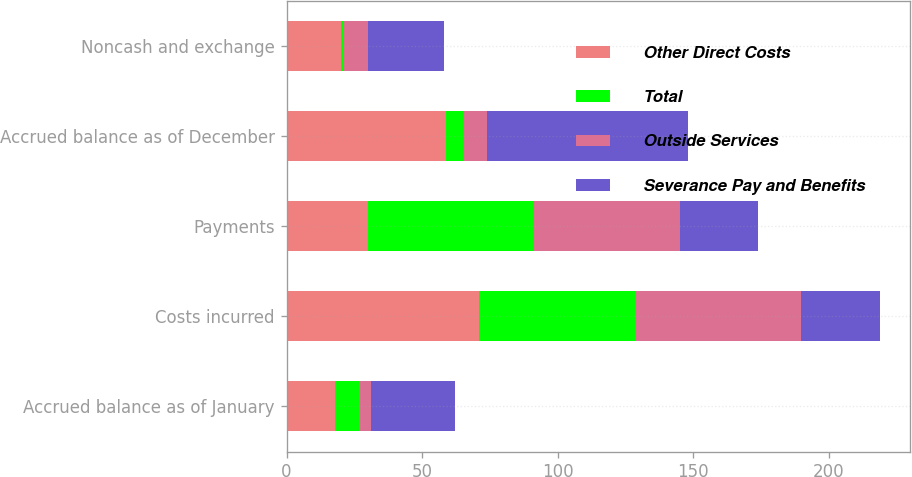Convert chart. <chart><loc_0><loc_0><loc_500><loc_500><stacked_bar_chart><ecel><fcel>Accrued balance as of January<fcel>Costs incurred<fcel>Payments<fcel>Accrued balance as of December<fcel>Noncash and exchange<nl><fcel>Other Direct Costs<fcel>18<fcel>71<fcel>30<fcel>59<fcel>20<nl><fcel>Total<fcel>9<fcel>58<fcel>61<fcel>6<fcel>1<nl><fcel>Outside Services<fcel>4<fcel>61<fcel>54<fcel>9<fcel>9<nl><fcel>Severance Pay and Benefits<fcel>31<fcel>29<fcel>29<fcel>74<fcel>28<nl></chart> 